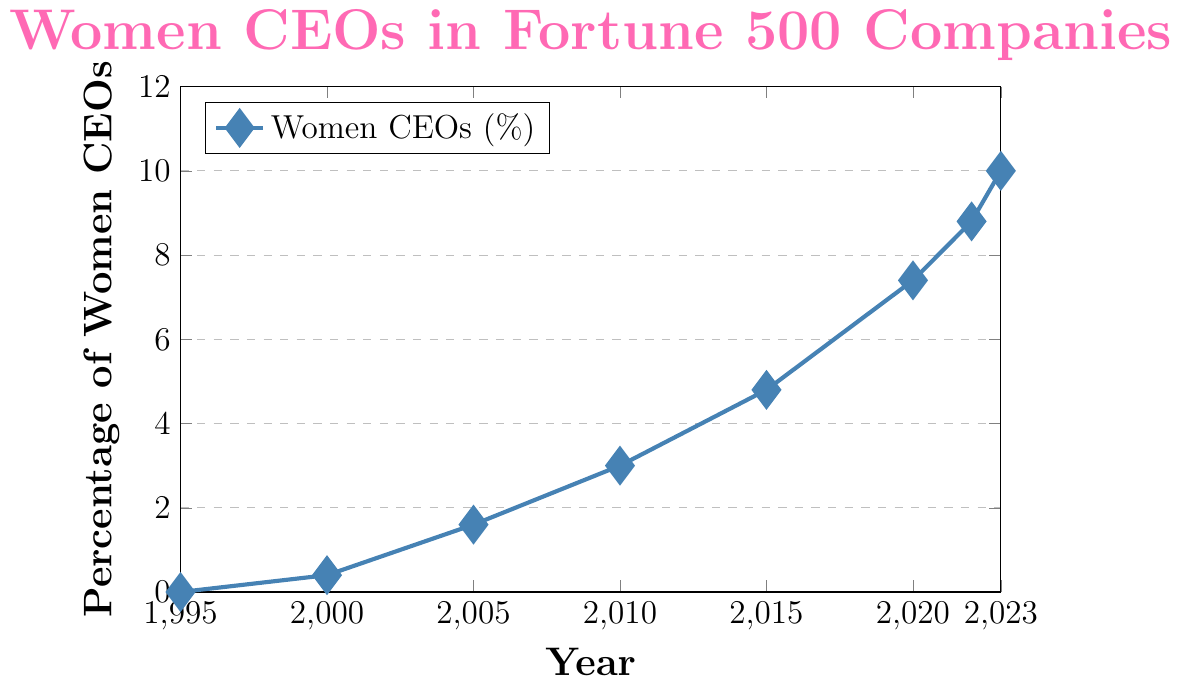What is the percentage of women CEOs in 2005? The chart shows a data point at (2005, 1.6), indicating that the percentage of women CEOs in Fortune 500 companies in 2005 is 1.6%.
Answer: 1.6% By how many percentage points did the number of women CEOs increase between 2010 and 2023? The percentage of women CEOs in 2010 is 3.0%, and in 2023 it is 10.0%. The increase in percentage points is calculated by subtracting 3.0% from 10.0%, which is 10.0% - 3.0% = 7.0%.
Answer: 7.0% What is the average percentage of women CEOs between 1995 and 2023? The percentages of women CEOs across the years provided are 0.0, 0.4, 1.6, 3.0, 4.8, 7.4, 8.8, and 10.0. First, sum these up: 0.0+0.4+1.6+3.0+4.8+7.4+8.8+10.0 = 36.0. Next, divide the sum by the number of data points: 36.0 / 8 = 4.5.
Answer: 4.5% During which period was the rate of increase in women CEOs the highest? To determine the period with the highest rate of increase, observe the steepness of the line segments. The most significant visible increase is from 2020 (7.4%) to 2023 (10.0%), implying a rate of increase of 2.6 percentage points over 3 years. Comparatively, other periods show smaller increases.
Answer: 2020 to 2023 In which year did the percentage of women CEOs first exceed 5%? By examining the line chart, notice the first year where the percentage surpasses 5% is displayed clearly on the upward slope. The data points show that in 2015, the percentage of women CEOs is 4.8% and in 2020 it is 7.4%. Thus, the first year exceeding 5% is 2020.
Answer: 2020 What trend can be observed in the line chart from 1995 to 2023? The line chart shows a general upward trend of the percentage of women CEOs in Fortune 500 companies from 1995 to 2023. The line starts at 0.0% in 1995 and steadily increases over the years, reflecting growing representation of women in leadership.
Answer: Upward trend How much did the percentage of women CEOs increase from 2015 to 2023? Observing the chart, the percentage of women CEOs in 2015 is 4.8% and in 2023 is 10.0%. By calculating the difference: 10.0% - 4.8%, we find it increased by 5.2 percentage points.
Answer: 5.2% Compare the growth in percentage of women CEOs from 2000 to 2010 with that from 2010 to 2020. In 2000, the percentage is 0.4%, and in 2010 it is 3.0%. The growth over this period is 3.0% - 0.4% = 2.6%. From 2010 to 2020, the increase is from 3.0% to 7.4%, calculated as 7.4% - 3.0% = 4.4%. Since 4.4% (2010-2020) is greater than 2.6% (2000-2010), growth was faster in the latter period.
Answer: Faster growth 2010-2020 By what factor did the percentage of women CEOs increase from 1995 to 2023? The chart shows a percentage of 0.0% in 1995 and 10.0% in 2023. Since the initial percentage in 1995 is 0.0%, we cannot calculate a factor increase directly as it implies division by zero. Thus, it started from zero and reached 10.0% by 2023.
Answer: Cannot calculate directly 